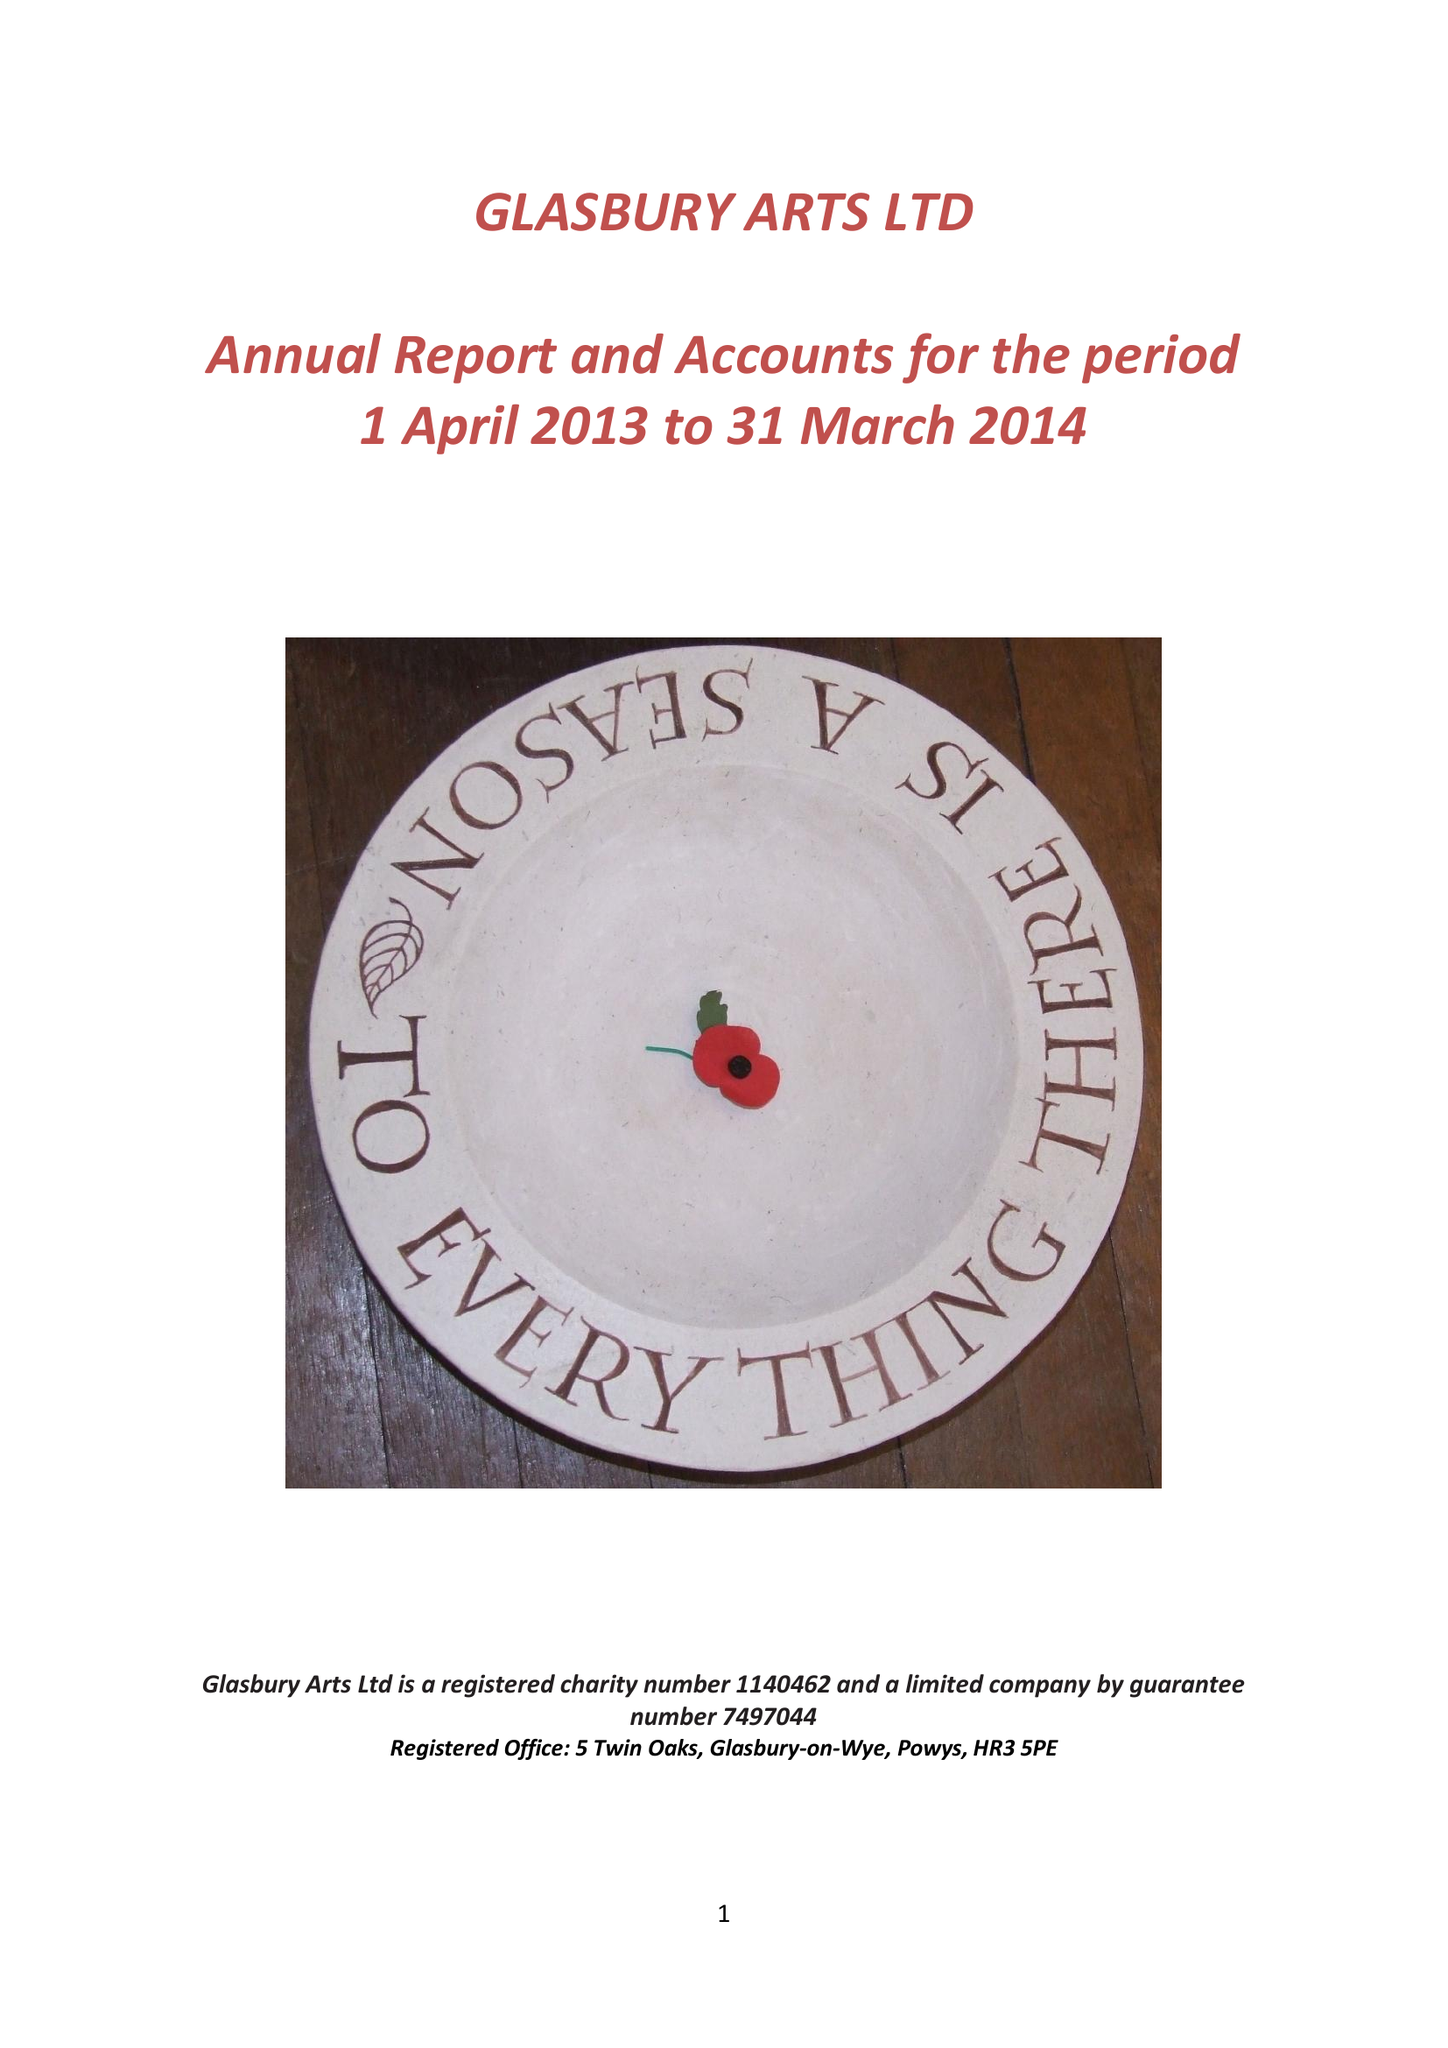What is the value for the address__post_town?
Answer the question using a single word or phrase. HEREFORD 